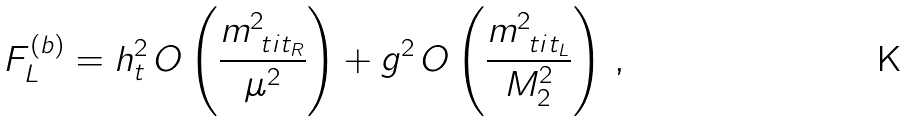Convert formula to latex. <formula><loc_0><loc_0><loc_500><loc_500>F _ { L } ^ { ( b ) } = h _ { t } ^ { 2 } \, O \left ( \frac { m _ { \ t i { t } _ { R } } ^ { 2 } } { \mu ^ { 2 } } \right ) + g ^ { 2 } \, O \left ( \frac { m _ { \ t i { t } _ { L } } ^ { 2 } } { M _ { 2 } ^ { 2 } } \right ) \, ,</formula> 